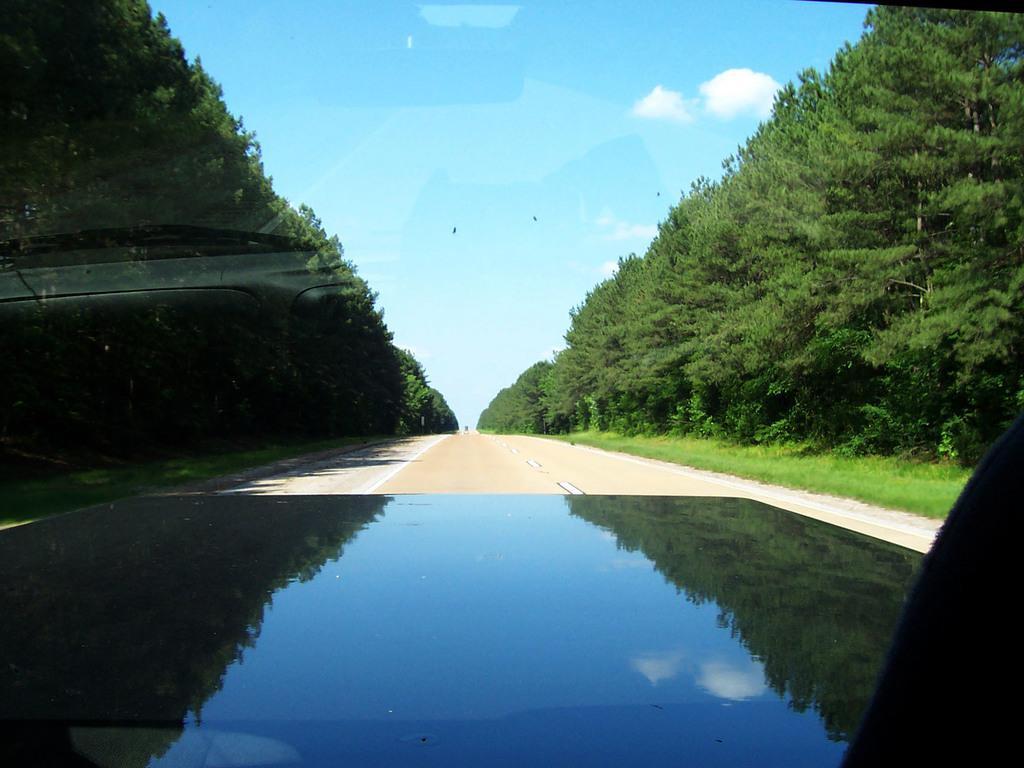Please provide a concise description of this image. In this image I can see the vehicle on the road. On both sides of the road I can see many trees. In the background I can see the clouds and the sky. 